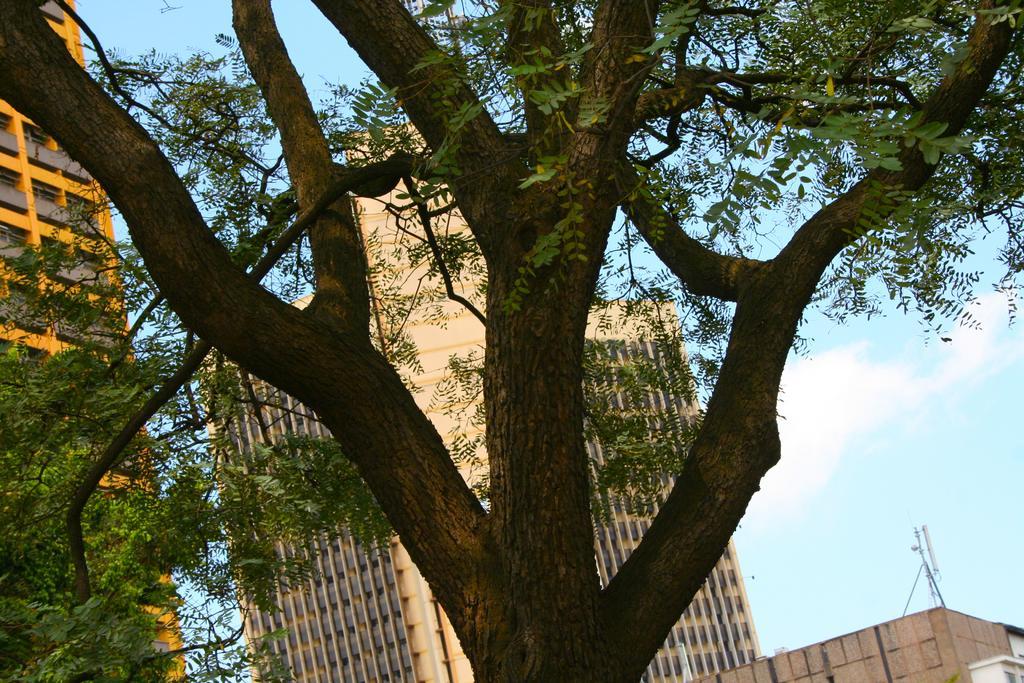How would you summarize this image in a sentence or two? In this image I can see few trees in the front. In the background I can see few buildings, clouds and the sky. On the bottom right side of the image I can see a thing on the one building. 